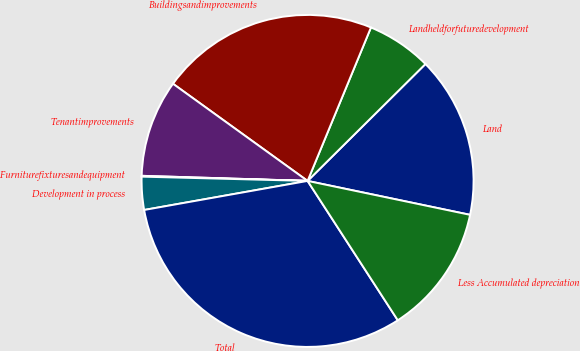Convert chart. <chart><loc_0><loc_0><loc_500><loc_500><pie_chart><fcel>Land<fcel>Landheldforfuturedevelopment<fcel>Buildingsandimprovements<fcel>Tenantimprovements<fcel>Furniturefixturesandequipment<fcel>Development in process<fcel>Total<fcel>Less Accumulated depreciation<nl><fcel>15.71%<fcel>6.33%<fcel>21.28%<fcel>9.46%<fcel>0.08%<fcel>3.21%<fcel>31.34%<fcel>12.58%<nl></chart> 